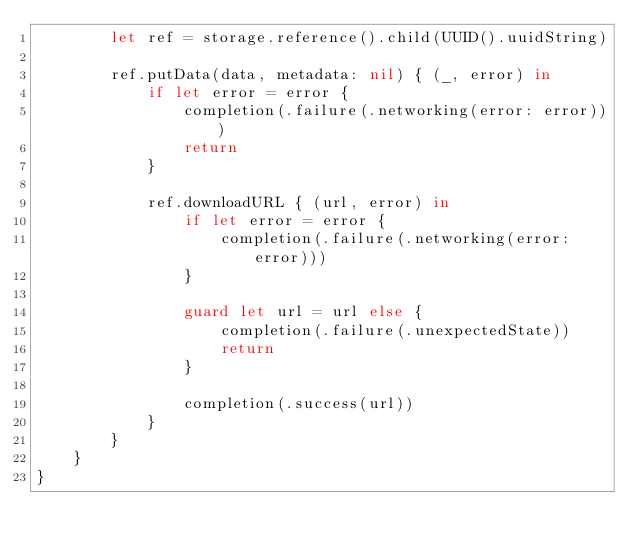Convert code to text. <code><loc_0><loc_0><loc_500><loc_500><_Swift_>        let ref = storage.reference().child(UUID().uuidString)
        
        ref.putData(data, metadata: nil) { (_, error) in
            if let error = error {
                completion(.failure(.networking(error: error)))
                return
            }
            
            ref.downloadURL { (url, error) in
                if let error = error {
                    completion(.failure(.networking(error: error)))
                }
                
                guard let url = url else {
                    completion(.failure(.unexpectedState))
                    return
                }
                
                completion(.success(url))
            }
        }
    }
}
</code> 